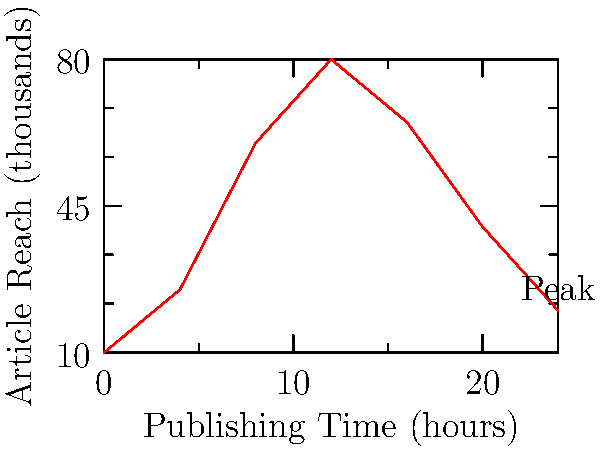Based on the graph showing the correlation between publishing time and article reach, at approximately what time should you publish your articles to maximize reach? To determine the optimal publishing time for maximum article reach, we need to analyze the graph:

1. The x-axis represents the publishing time in hours (0-24).
2. The y-axis represents the article reach in thousands.
3. The red line shows the correlation between publishing time and reach.

We can observe that:

1. The reach starts low at 0 hours (midnight).
2. It steadily increases until it reaches a peak.
3. After the peak, the reach gradually decreases.

To find the optimal publishing time:

1. Locate the highest point on the graph.
2. This point occurs at approximately 12 hours on the x-axis.
3. 12 hours corresponds to 12:00 PM or noon.

Therefore, to maximize article reach, you should aim to publish your articles around noon (12:00 PM).
Answer: 12:00 PM (noon) 